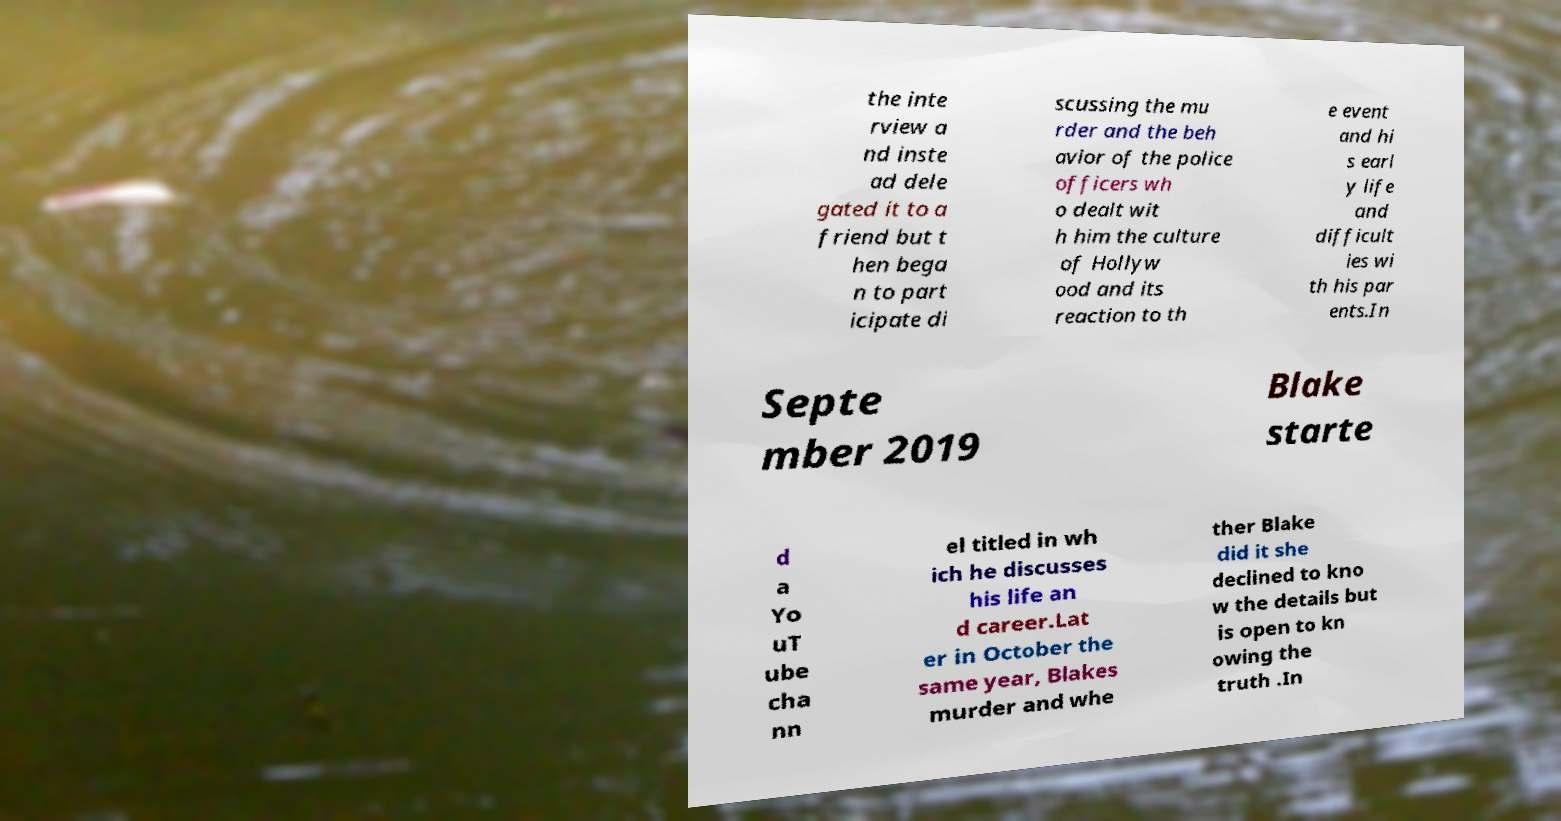Please read and relay the text visible in this image. What does it say? the inte rview a nd inste ad dele gated it to a friend but t hen bega n to part icipate di scussing the mu rder and the beh avior of the police officers wh o dealt wit h him the culture of Hollyw ood and its reaction to th e event and hi s earl y life and difficult ies wi th his par ents.In Septe mber 2019 Blake starte d a Yo uT ube cha nn el titled in wh ich he discusses his life an d career.Lat er in October the same year, Blakes murder and whe ther Blake did it she declined to kno w the details but is open to kn owing the truth .In 